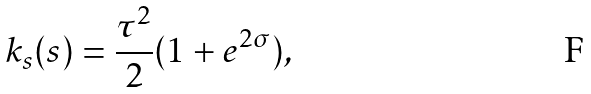<formula> <loc_0><loc_0><loc_500><loc_500>k _ { s } ( s ) = \frac { \tau ^ { 2 } } { 2 } ( 1 + e ^ { 2 \sigma } ) ,</formula> 